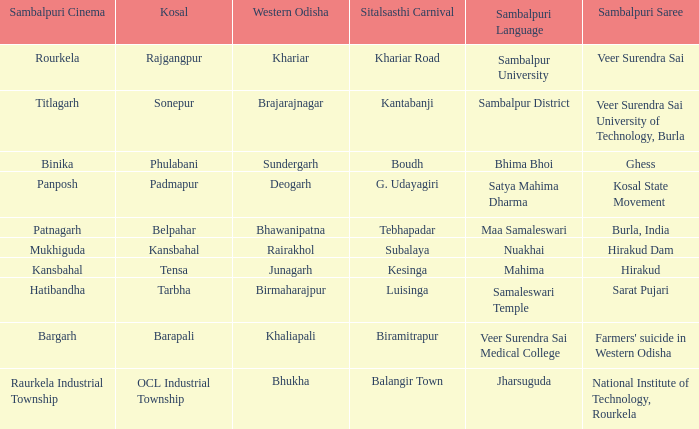What is the sitalsasthi festival with sonepur as kosal? Kantabanji. 